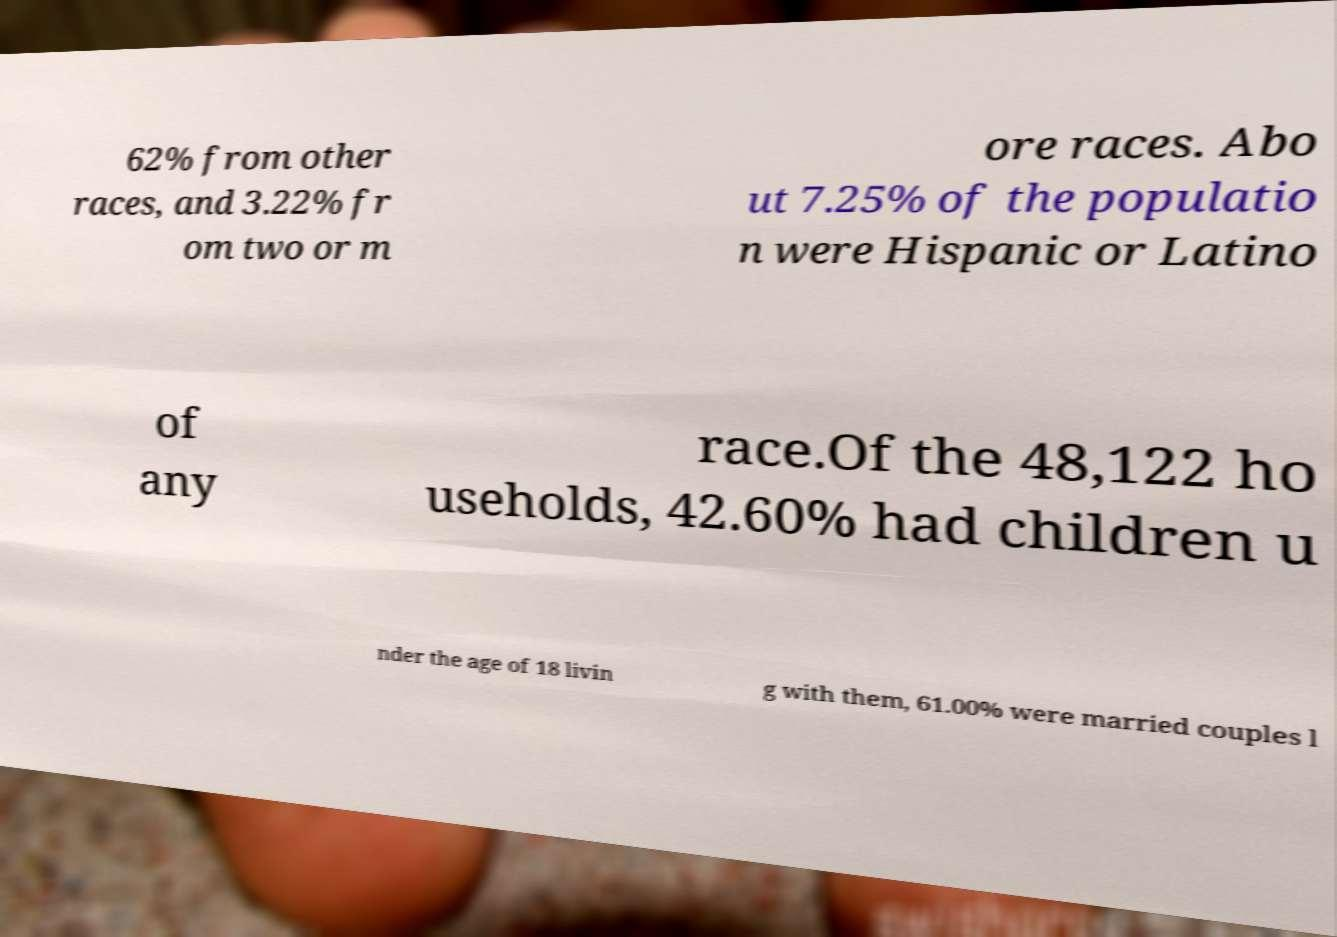What messages or text are displayed in this image? I need them in a readable, typed format. 62% from other races, and 3.22% fr om two or m ore races. Abo ut 7.25% of the populatio n were Hispanic or Latino of any race.Of the 48,122 ho useholds, 42.60% had children u nder the age of 18 livin g with them, 61.00% were married couples l 